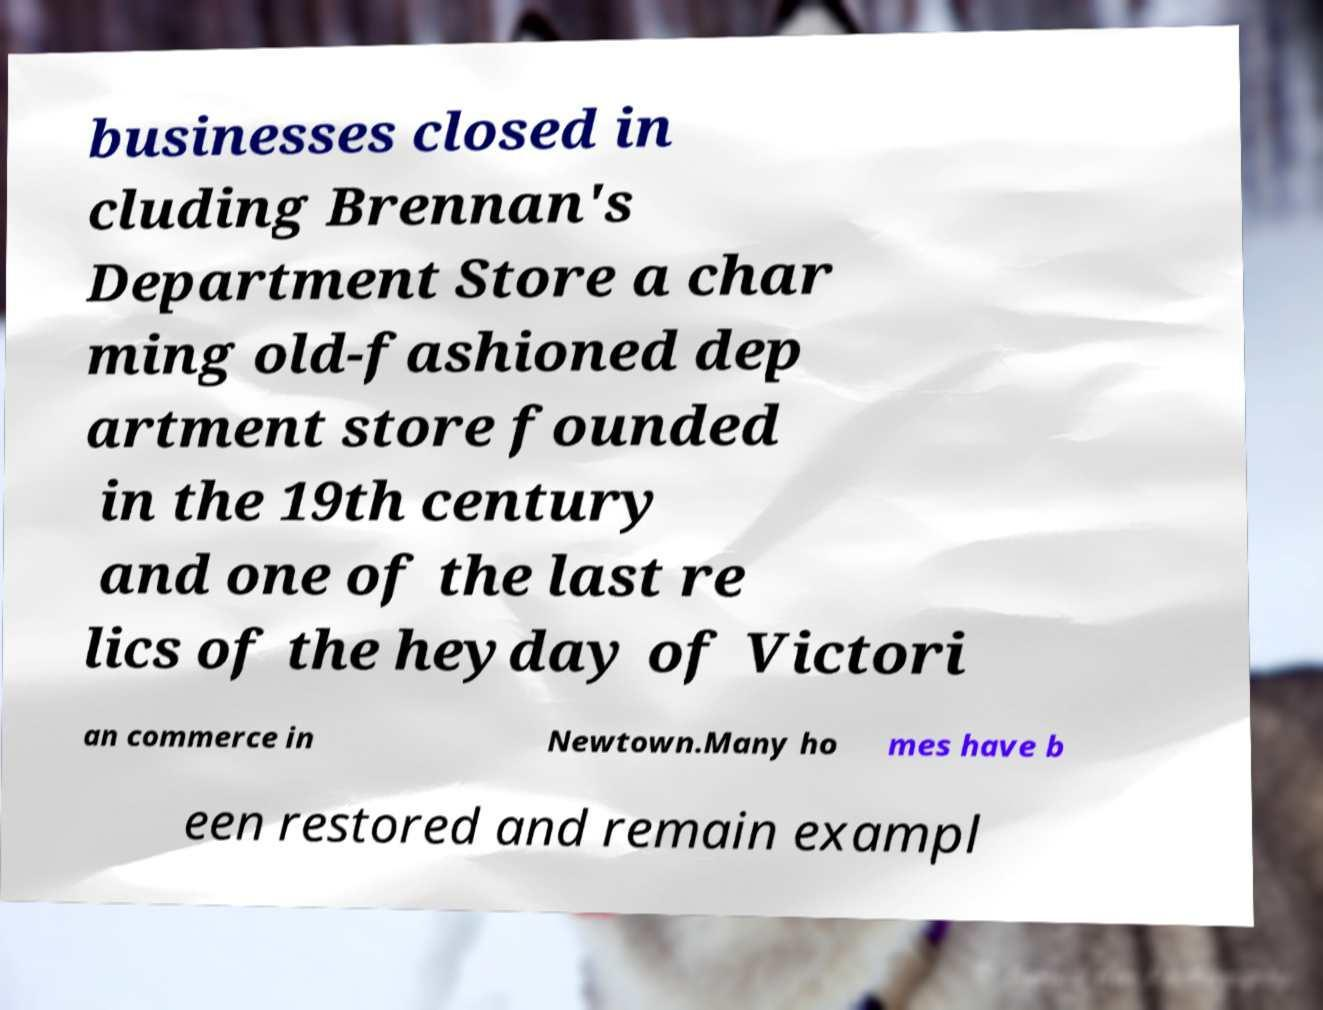For documentation purposes, I need the text within this image transcribed. Could you provide that? businesses closed in cluding Brennan's Department Store a char ming old-fashioned dep artment store founded in the 19th century and one of the last re lics of the heyday of Victori an commerce in Newtown.Many ho mes have b een restored and remain exampl 